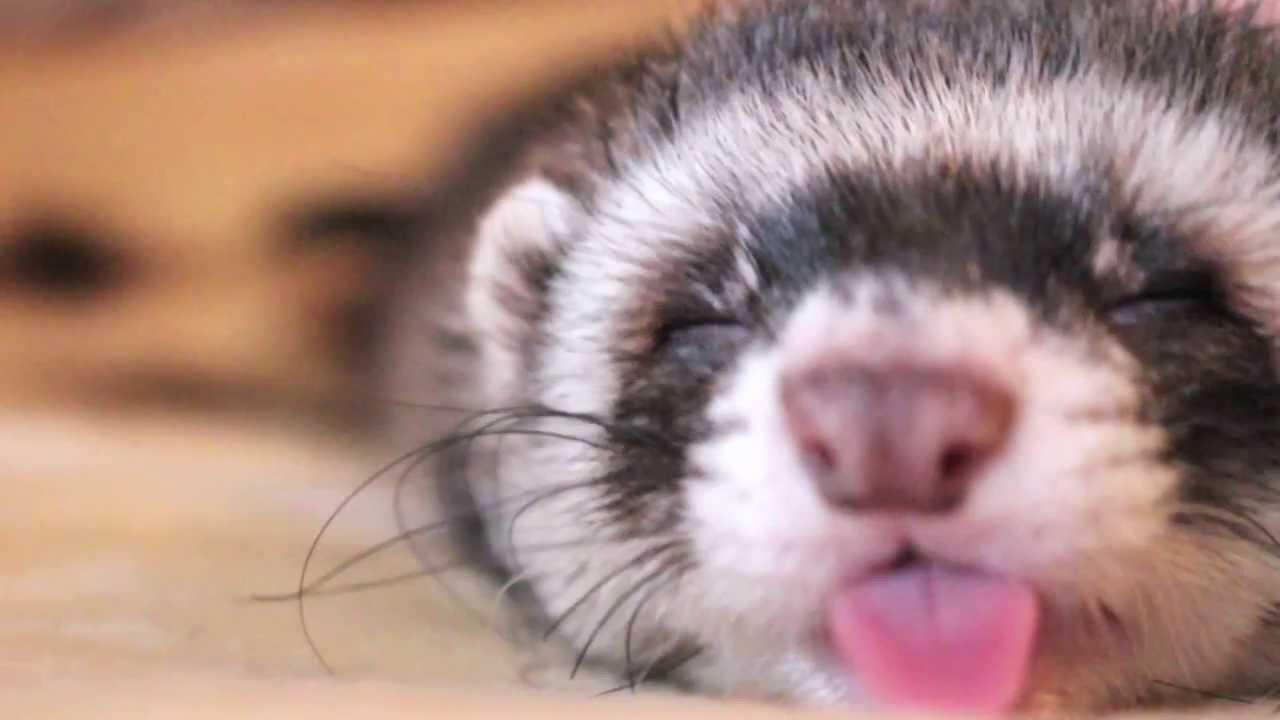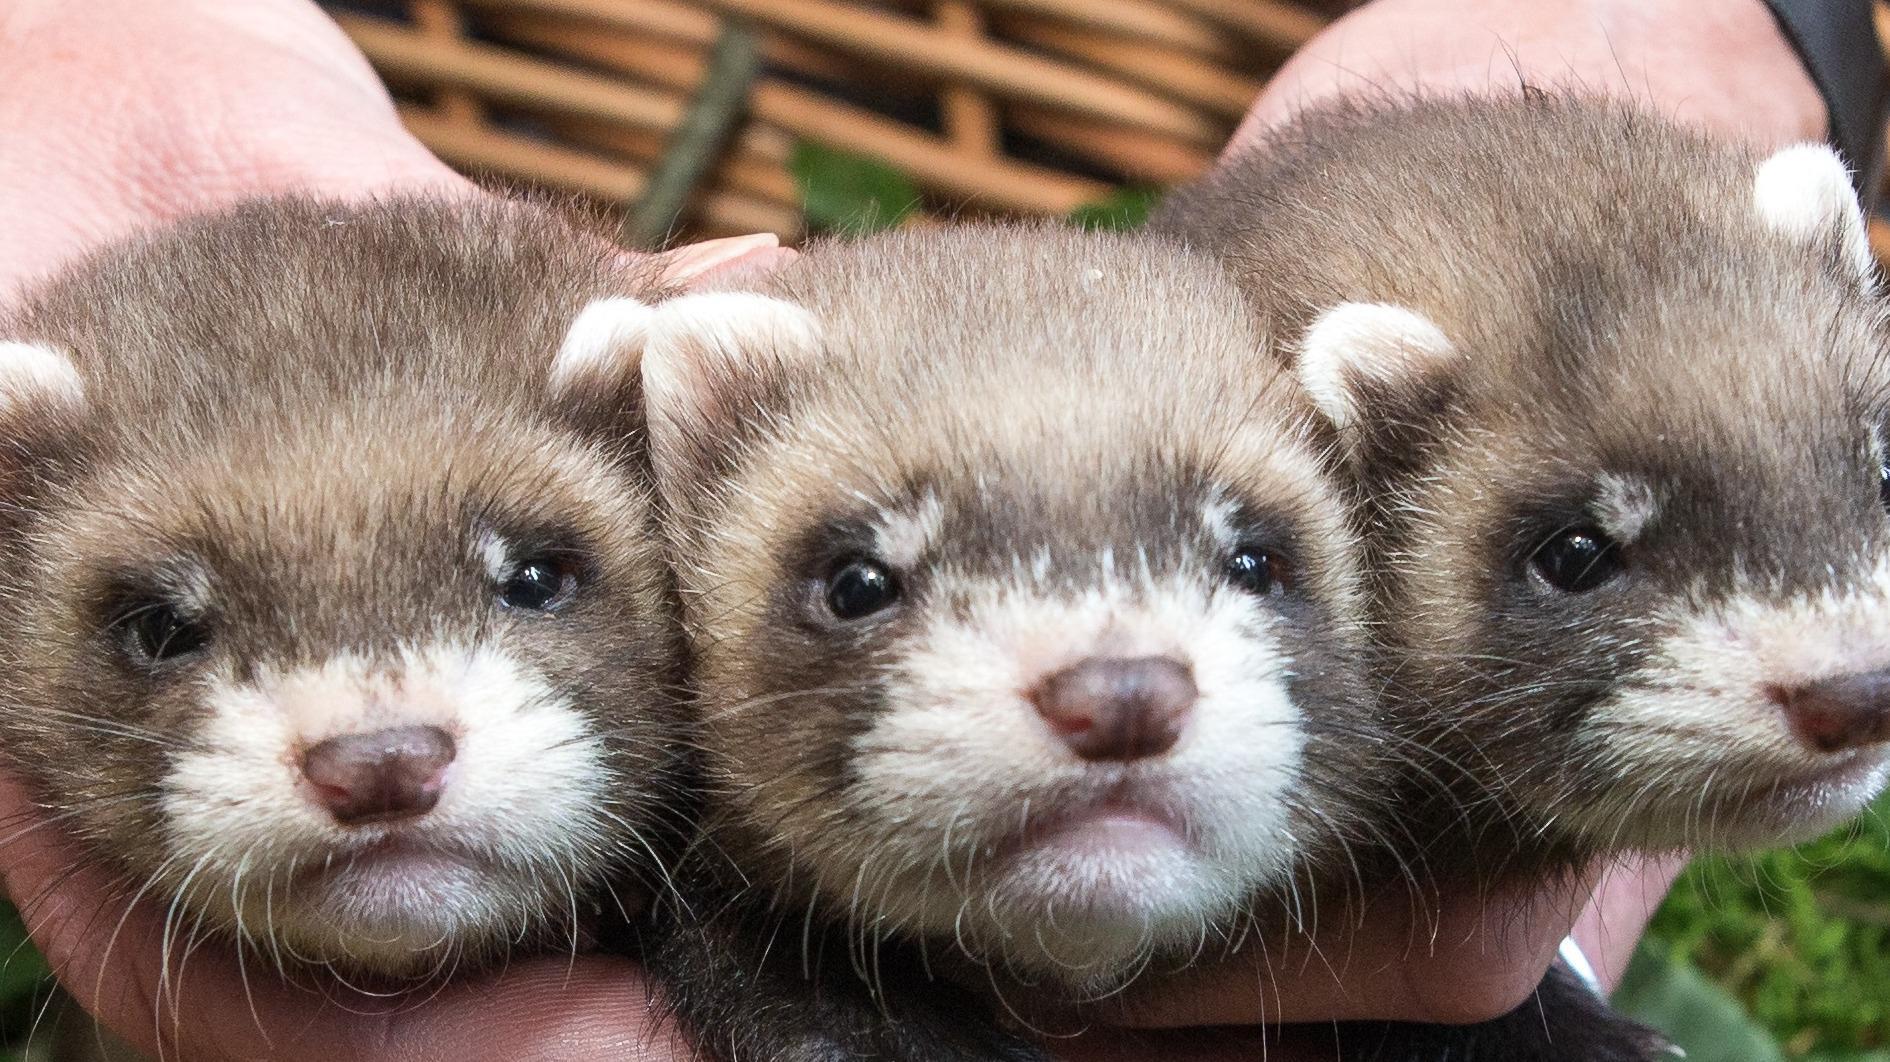The first image is the image on the left, the second image is the image on the right. Given the left and right images, does the statement "There is exactly three ferrets in the right image." hold true? Answer yes or no. Yes. The first image is the image on the left, the second image is the image on the right. Given the left and right images, does the statement "there are 3 ferrets being helpd up together by human hands" hold true? Answer yes or no. Yes. 